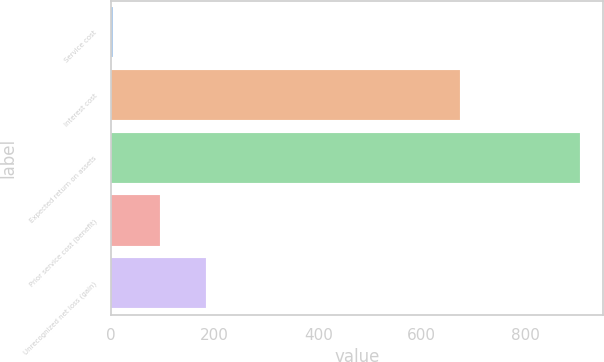Convert chart to OTSL. <chart><loc_0><loc_0><loc_500><loc_500><bar_chart><fcel>Service cost<fcel>Interest cost<fcel>Expected return on assets<fcel>Prior service cost (benefit)<fcel>Unrecognized net loss (gain)<nl><fcel>3<fcel>674<fcel>905<fcel>93.2<fcel>183.4<nl></chart> 